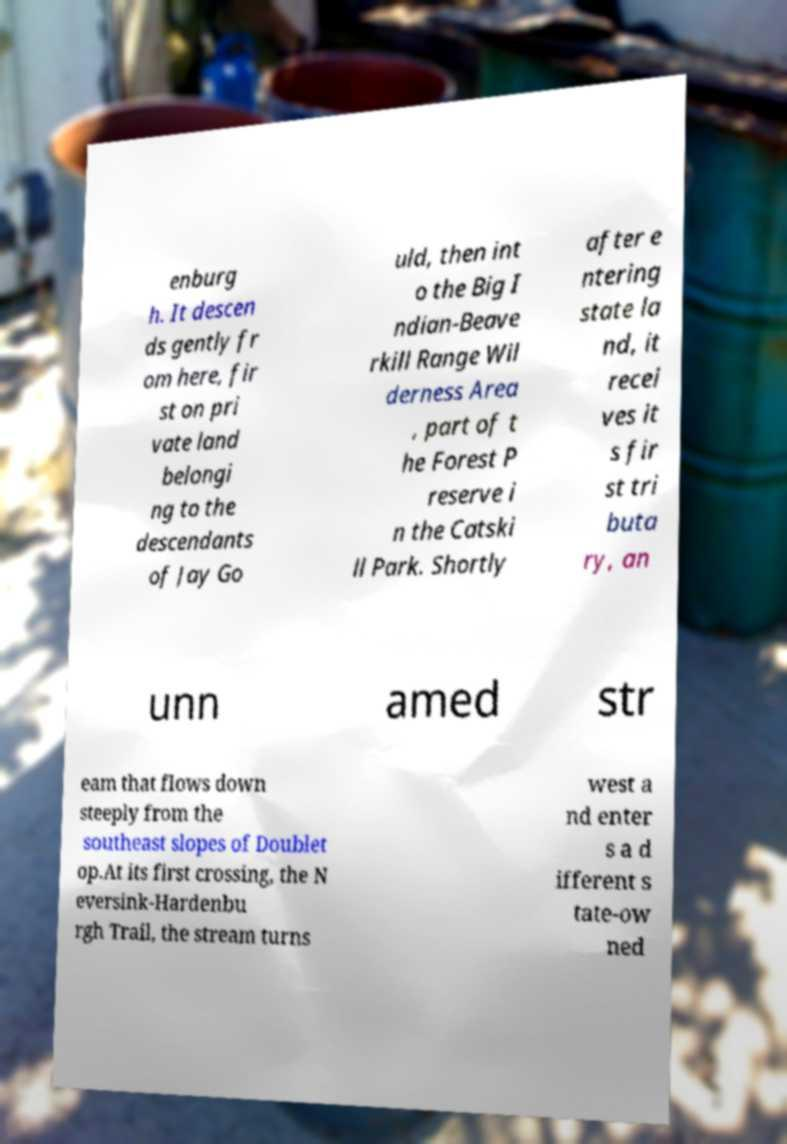Please identify and transcribe the text found in this image. enburg h. It descen ds gently fr om here, fir st on pri vate land belongi ng to the descendants of Jay Go uld, then int o the Big I ndian-Beave rkill Range Wil derness Area , part of t he Forest P reserve i n the Catski ll Park. Shortly after e ntering state la nd, it recei ves it s fir st tri buta ry, an unn amed str eam that flows down steeply from the southeast slopes of Doublet op.At its first crossing, the N eversink-Hardenbu rgh Trail, the stream turns west a nd enter s a d ifferent s tate-ow ned 